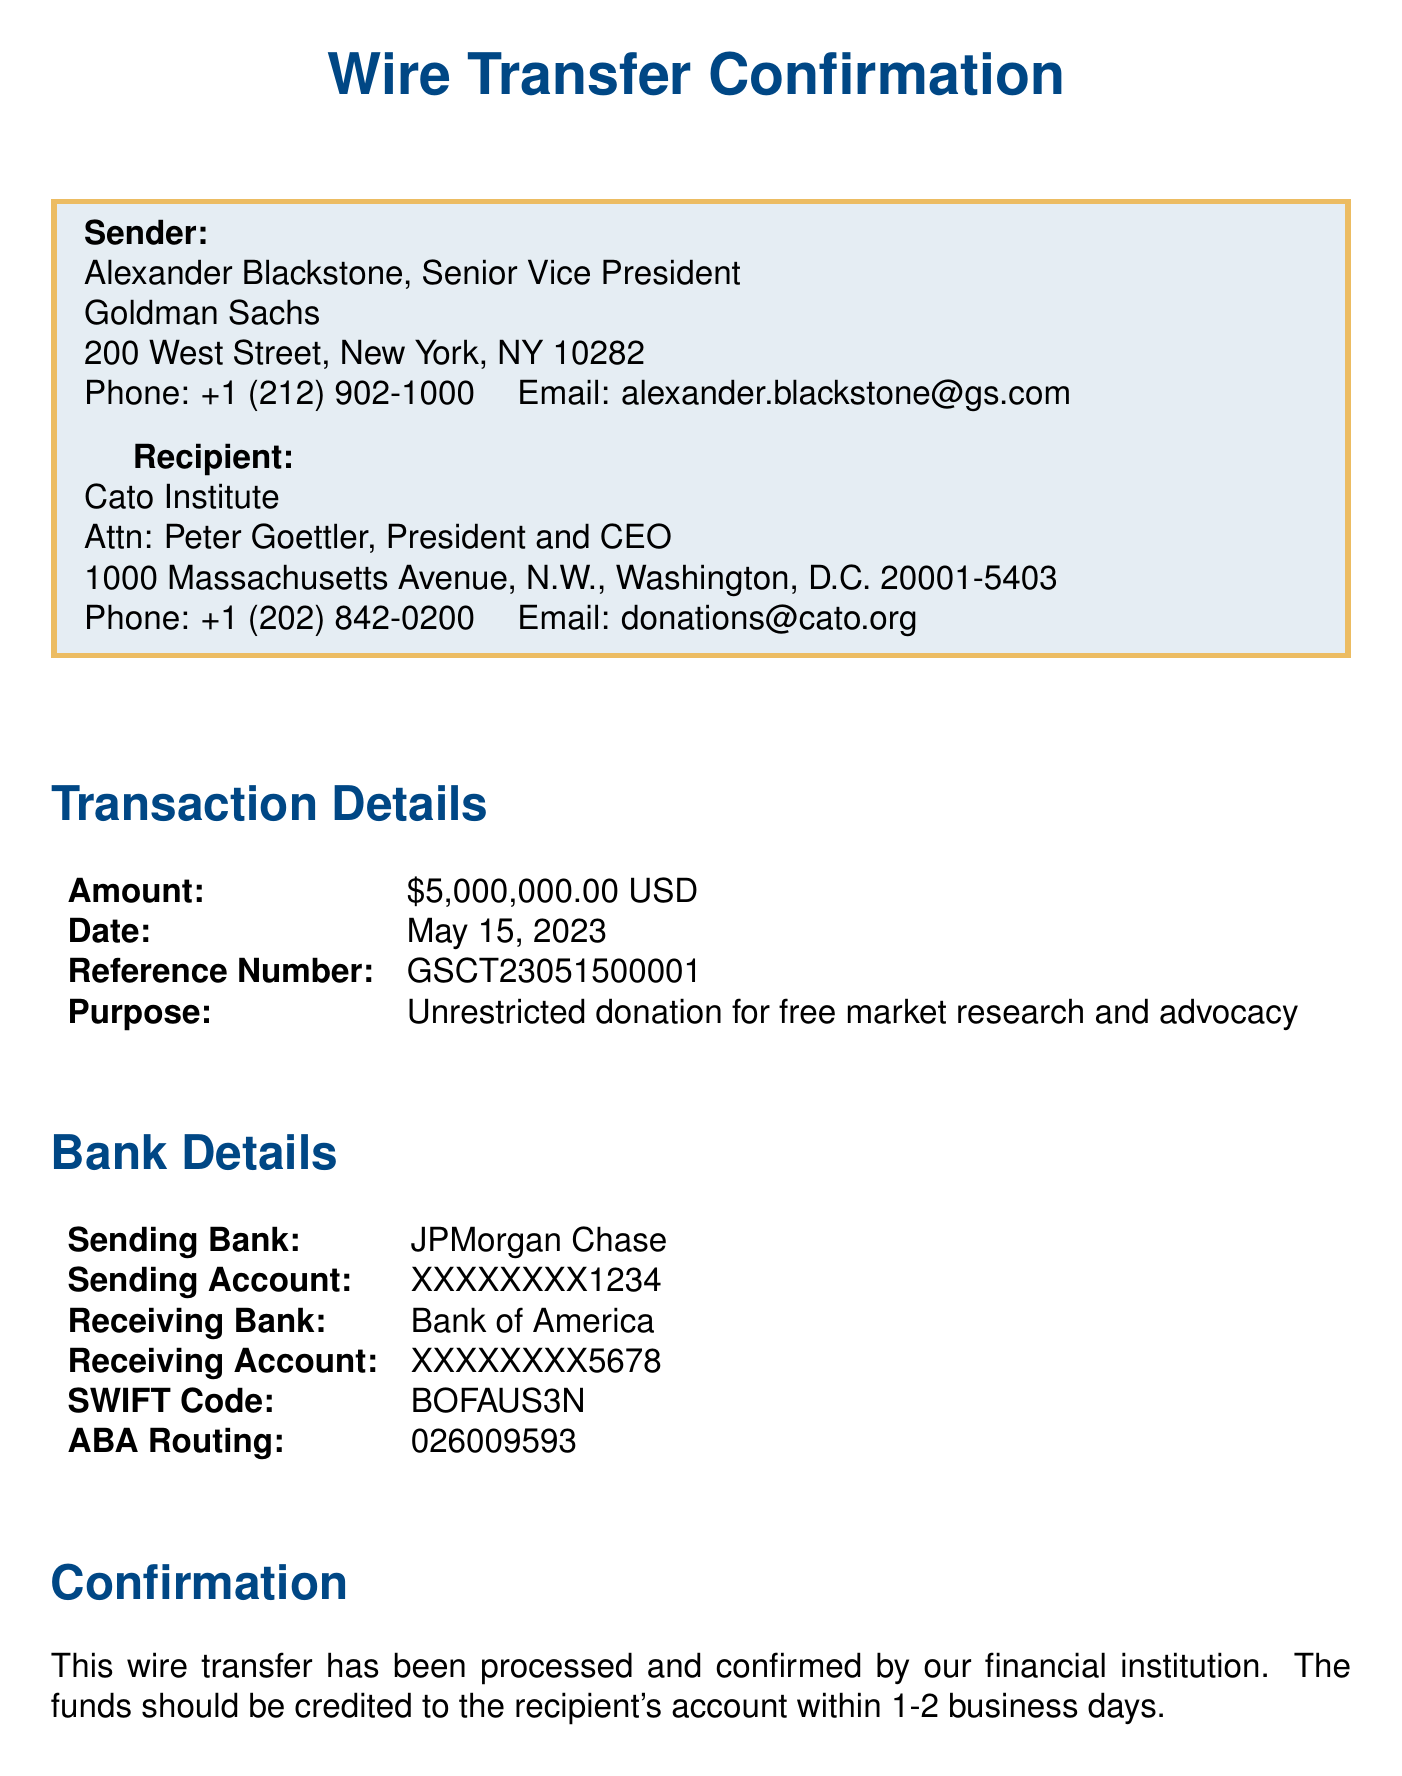What is the name of the sender? The sender's name is provided in the document as Alexander Blackstone.
Answer: Alexander Blackstone What is the amount of the donation? The document states the amount of the donation as $5,000,000.00.
Answer: $5,000,000.00 What is the date of the transaction? The transaction date is specified in the document as May 15, 2023.
Answer: May 15, 2023 Who is the attention person listed for the recipient? The recipient's attention person, indicated in the document, is Peter Goettler.
Answer: Peter Goettler Which bank is the sending bank? The document lists JPMorgan Chase as the sending bank for the wire transfer.
Answer: JPMorgan Chase What is the purpose of the donation? The purpose of the donation is clarified in the document as unrestricted donation for free market research and advocacy.
Answer: Unrestricted donation for free market research and advocacy What is the compliance note mentioned? The compliance note states that the transaction has been reviewed and approved in accordance with all applicable anti-money laundering and know your customer regulations.
Answer: Approved in accordance with all applicable anti-money laundering and know your customer regulations How many business days until follow-up action? The follow-up action is scheduled to occur within 5 business days, as indicated in the document.
Answer: 5 business days When is the recipient expected to receive the funds? The document mentions that the funds should be credited to the recipient's account within 1-2 business days.
Answer: 1-2 business days 